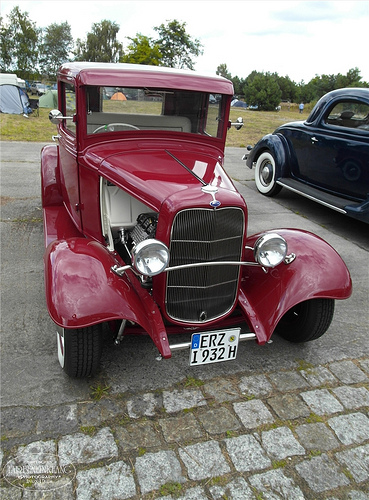<image>
Can you confirm if the red car is behind the black car? No. The red car is not behind the black car. From this viewpoint, the red car appears to be positioned elsewhere in the scene. 